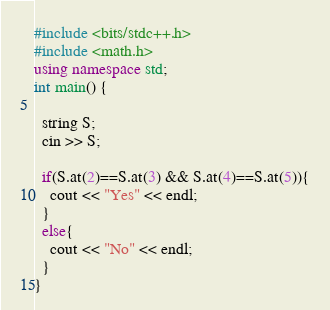Convert code to text. <code><loc_0><loc_0><loc_500><loc_500><_C++_>#include <bits/stdc++.h>
#include <math.h>
using namespace std;
int main() {

  string S;
  cin >> S;
  
  if(S.at(2)==S.at(3) && S.at(4)==S.at(5)){
    cout << "Yes" << endl;
  }
  else{
    cout << "No" << endl;
  }
}</code> 